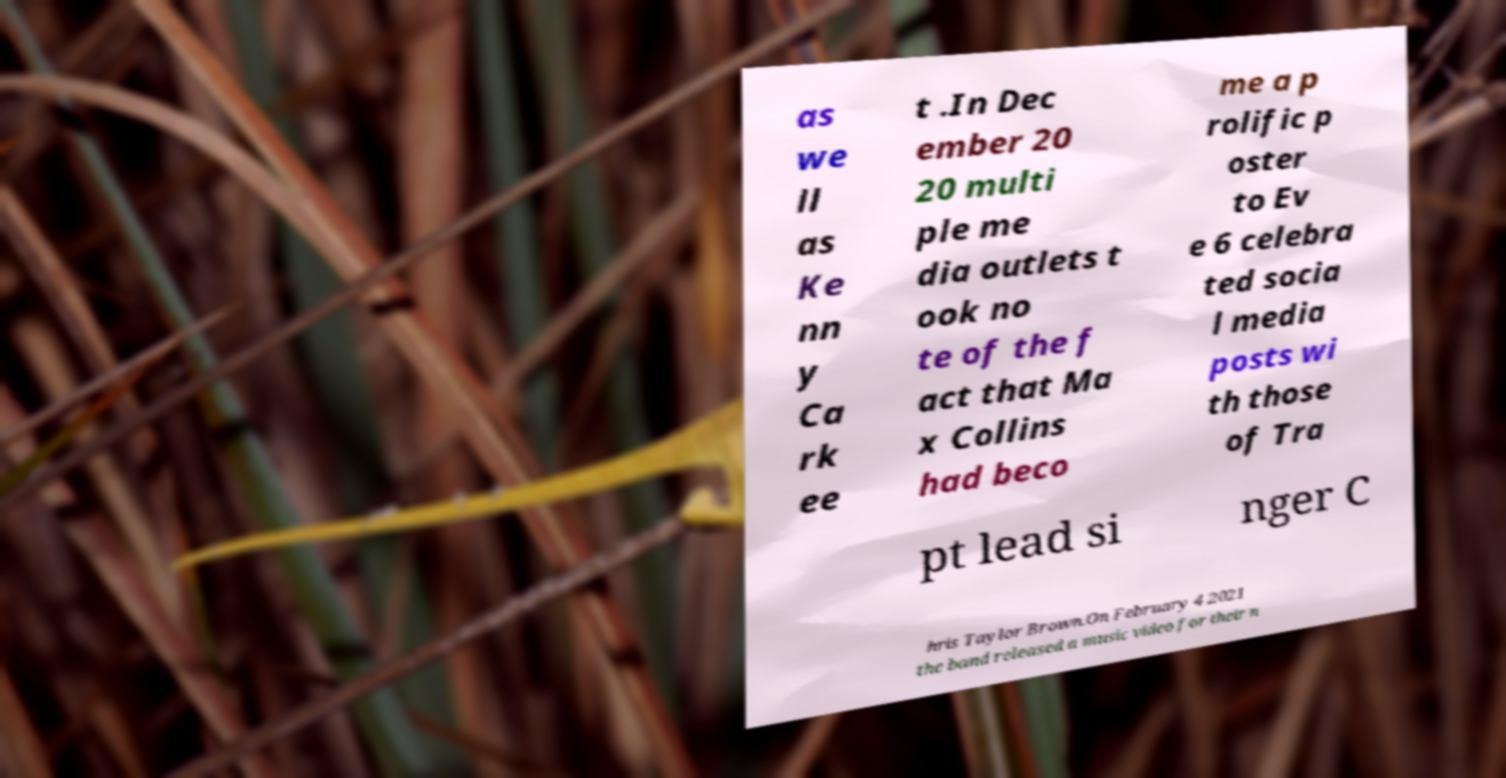For documentation purposes, I need the text within this image transcribed. Could you provide that? as we ll as Ke nn y Ca rk ee t .In Dec ember 20 20 multi ple me dia outlets t ook no te of the f act that Ma x Collins had beco me a p rolific p oster to Ev e 6 celebra ted socia l media posts wi th those of Tra pt lead si nger C hris Taylor Brown.On February 4 2021 the band released a music video for their n 